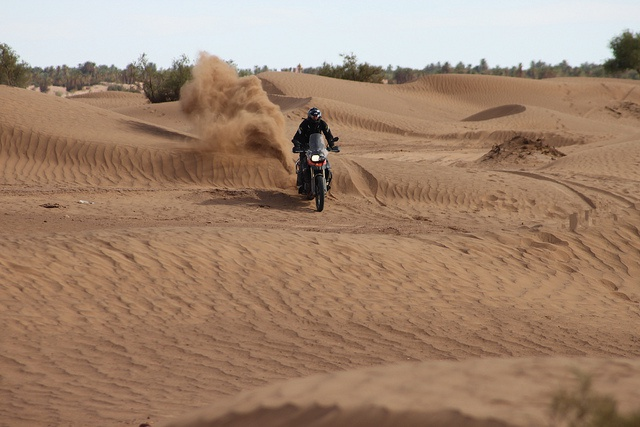Describe the objects in this image and their specific colors. I can see motorcycle in lightgray, black, gray, and tan tones and people in lightgray, black, gray, and maroon tones in this image. 